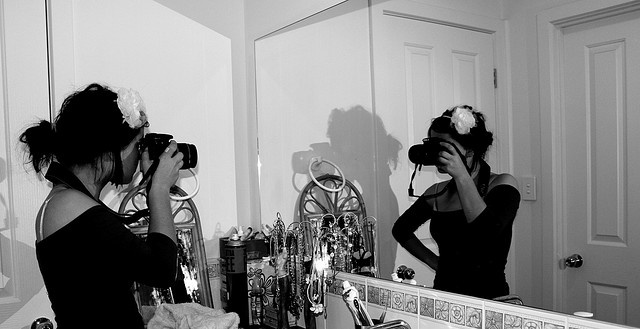Describe the objects in this image and their specific colors. I can see people in darkgray, black, gray, and lightgray tones, people in darkgray, black, gray, and lightgray tones, and toothbrush in darkgray, gray, black, and lightgray tones in this image. 